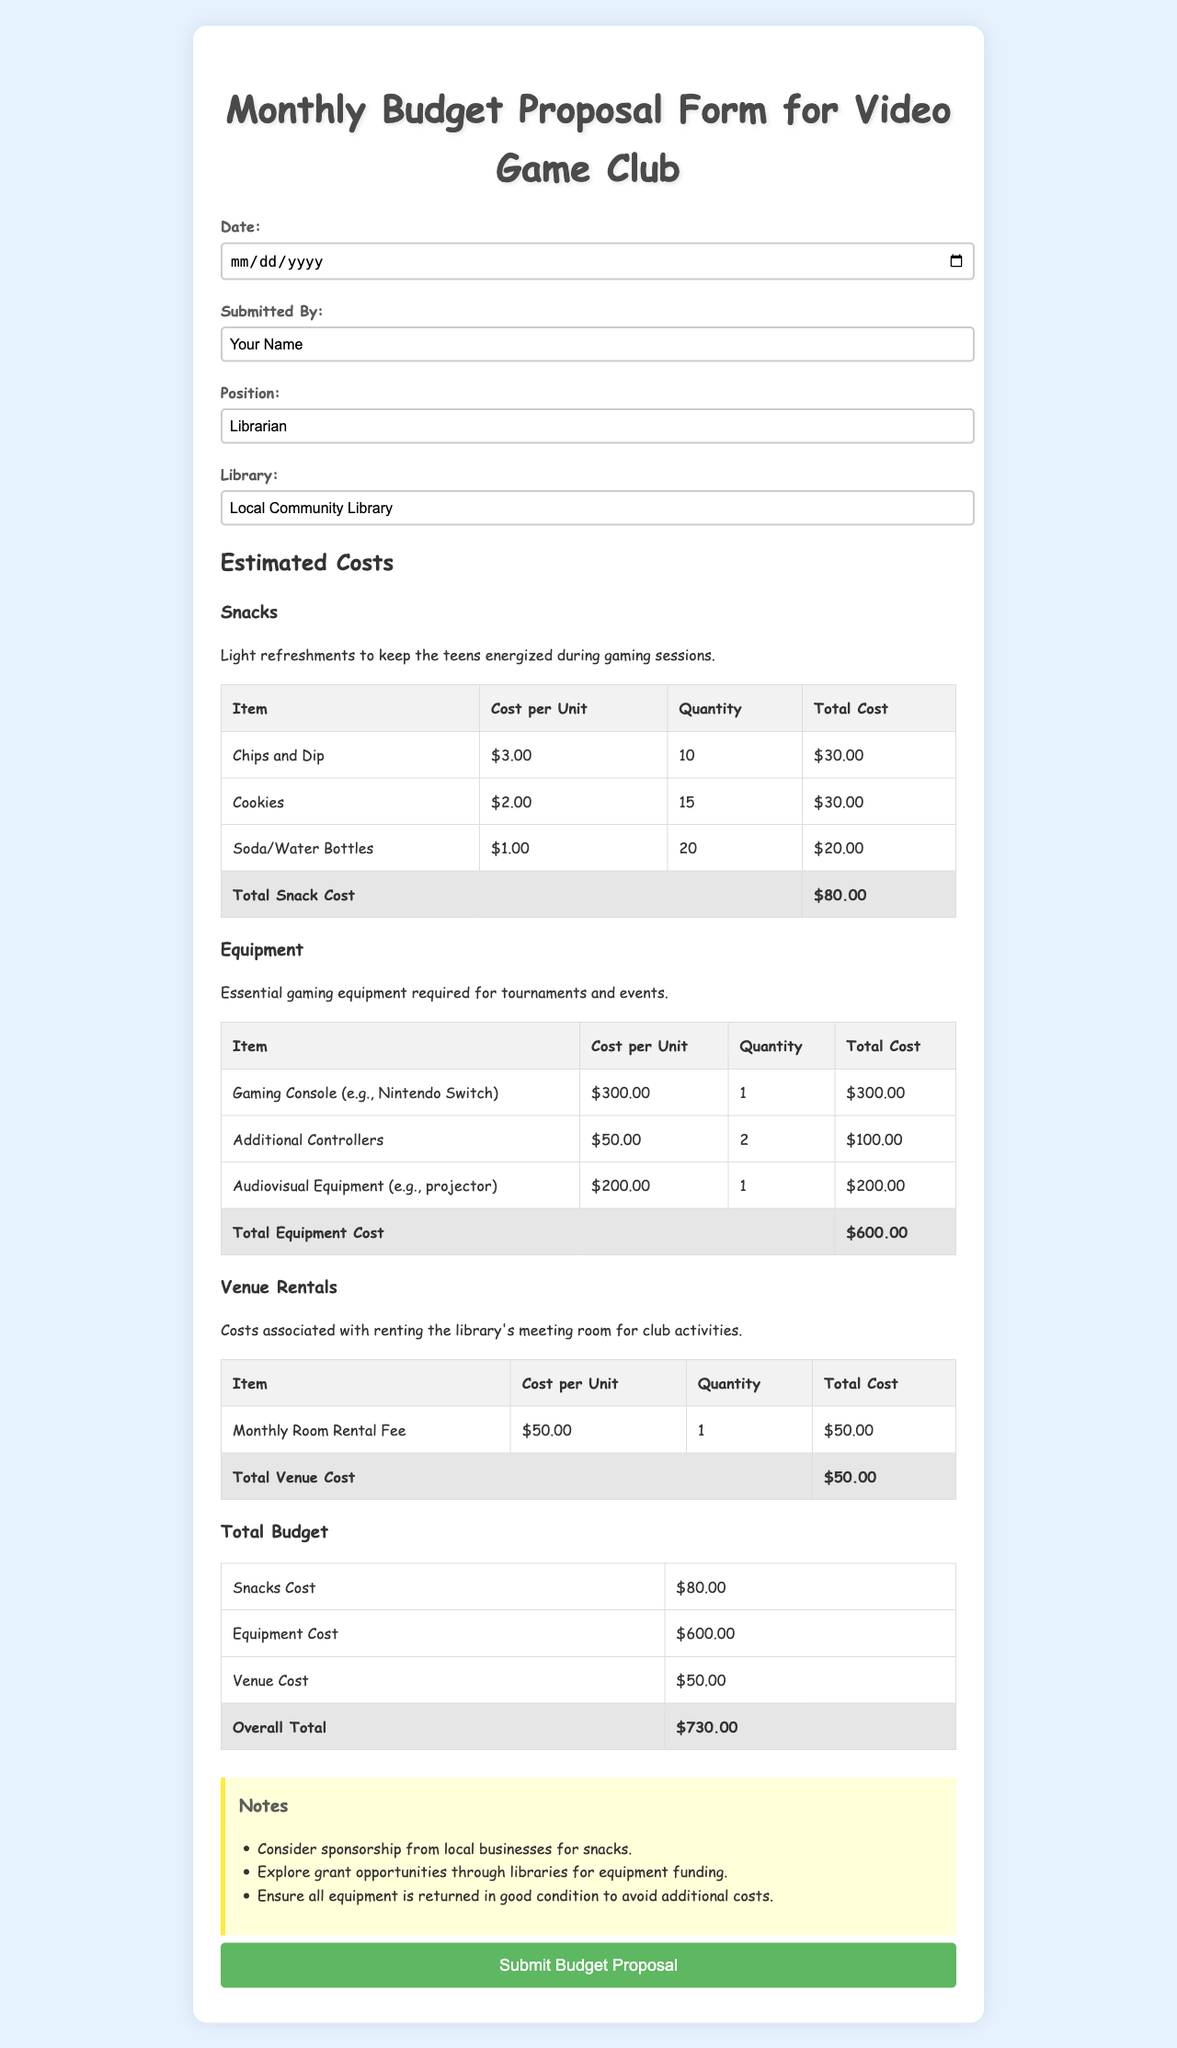What is the date of submission? The date of submission is the input date required in the form.
Answer: Required input Who submitted the budget proposal? The submitted by section in the form states the name of the person submitting the proposal.
Answer: Your Name What is the position of the person submitting the proposal? The position section indicates the role of the person within the library.
Answer: Librarian How much does the total snack cost amount to? The total snack cost can be found in the table summarizing snack expenses.
Answer: $80.00 What is the total cost for equipment? The total equipment cost is specified in the table outlining the expenses for gaming equipment.
Answer: $600.00 What is the total venue cost for the month? The venue cost is detailed in the section for venue rentals in the budget form.
Answer: $50.00 What is the overall total budget for the video game club? The overall total provides a summary of all expenses across snacks, equipment, and venue rentals.
Answer: $730.00 What type of equipment is mentioned for the gaming club? The equipment section lists specific items needed for the video game club activities.
Answer: Gaming Console, Additional Controllers, Audiovisual Equipment What notes were suggested for the proposal? The notes section provides additional recommendations related to the budget proposal.
Answer: Sponsorship, grant opportunities, condition of equipment How many soda/water bottles are planned for purchase? The table under snacks specifies the quantity planned for purchase of soda or water.
Answer: 20 